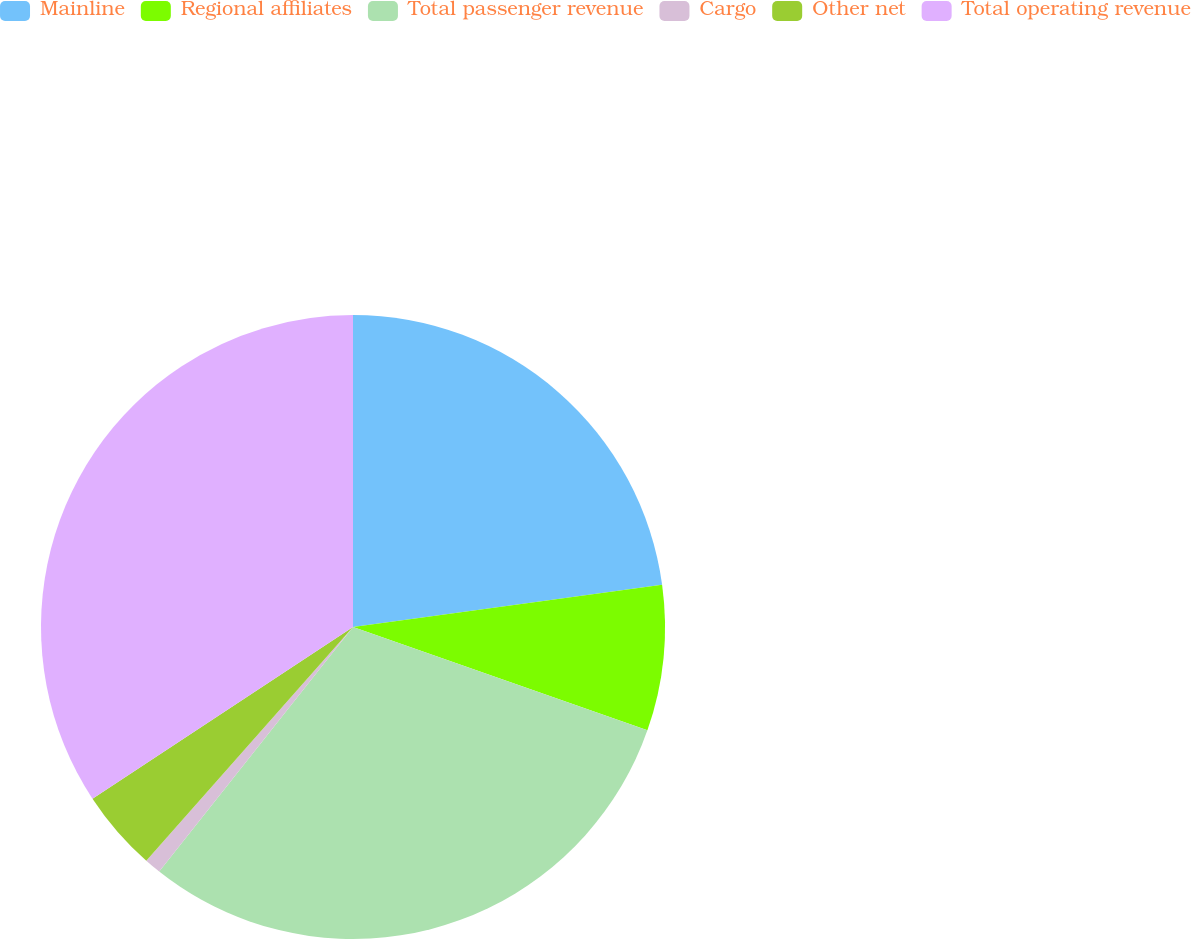Convert chart. <chart><loc_0><loc_0><loc_500><loc_500><pie_chart><fcel>Mainline<fcel>Regional affiliates<fcel>Total passenger revenue<fcel>Cargo<fcel>Other net<fcel>Total operating revenue<nl><fcel>22.83%<fcel>7.54%<fcel>30.29%<fcel>0.86%<fcel>4.2%<fcel>34.27%<nl></chart> 